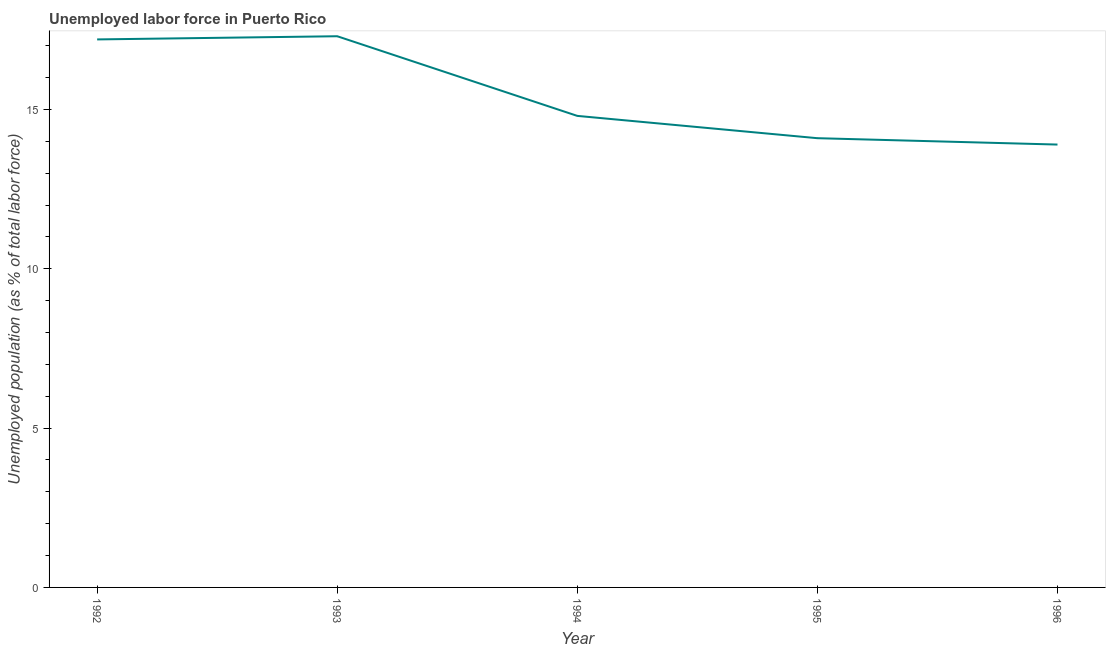What is the total unemployed population in 1996?
Make the answer very short. 13.9. Across all years, what is the maximum total unemployed population?
Provide a succinct answer. 17.3. Across all years, what is the minimum total unemployed population?
Your answer should be very brief. 13.9. In which year was the total unemployed population minimum?
Offer a very short reply. 1996. What is the sum of the total unemployed population?
Give a very brief answer. 77.3. What is the difference between the total unemployed population in 1992 and 1996?
Offer a very short reply. 3.3. What is the average total unemployed population per year?
Make the answer very short. 15.46. What is the median total unemployed population?
Give a very brief answer. 14.8. In how many years, is the total unemployed population greater than 8 %?
Your answer should be very brief. 5. Do a majority of the years between 1993 and 1992 (inclusive) have total unemployed population greater than 11 %?
Offer a very short reply. No. What is the ratio of the total unemployed population in 1994 to that in 1995?
Give a very brief answer. 1.05. Is the total unemployed population in 1993 less than that in 1995?
Your answer should be very brief. No. Is the difference between the total unemployed population in 1992 and 1995 greater than the difference between any two years?
Make the answer very short. No. What is the difference between the highest and the second highest total unemployed population?
Your answer should be compact. 0.1. What is the difference between the highest and the lowest total unemployed population?
Your response must be concise. 3.4. How many lines are there?
Make the answer very short. 1. How many years are there in the graph?
Provide a short and direct response. 5. Does the graph contain any zero values?
Keep it short and to the point. No. Does the graph contain grids?
Provide a short and direct response. No. What is the title of the graph?
Offer a very short reply. Unemployed labor force in Puerto Rico. What is the label or title of the Y-axis?
Offer a terse response. Unemployed population (as % of total labor force). What is the Unemployed population (as % of total labor force) in 1992?
Ensure brevity in your answer.  17.2. What is the Unemployed population (as % of total labor force) in 1993?
Ensure brevity in your answer.  17.3. What is the Unemployed population (as % of total labor force) in 1994?
Ensure brevity in your answer.  14.8. What is the Unemployed population (as % of total labor force) of 1995?
Your response must be concise. 14.1. What is the Unemployed population (as % of total labor force) in 1996?
Your answer should be compact. 13.9. What is the difference between the Unemployed population (as % of total labor force) in 1992 and 1993?
Give a very brief answer. -0.1. What is the difference between the Unemployed population (as % of total labor force) in 1992 and 1995?
Keep it short and to the point. 3.1. What is the difference between the Unemployed population (as % of total labor force) in 1992 and 1996?
Offer a terse response. 3.3. What is the difference between the Unemployed population (as % of total labor force) in 1993 and 1995?
Keep it short and to the point. 3.2. What is the difference between the Unemployed population (as % of total labor force) in 1994 and 1996?
Give a very brief answer. 0.9. What is the difference between the Unemployed population (as % of total labor force) in 1995 and 1996?
Make the answer very short. 0.2. What is the ratio of the Unemployed population (as % of total labor force) in 1992 to that in 1993?
Ensure brevity in your answer.  0.99. What is the ratio of the Unemployed population (as % of total labor force) in 1992 to that in 1994?
Offer a terse response. 1.16. What is the ratio of the Unemployed population (as % of total labor force) in 1992 to that in 1995?
Keep it short and to the point. 1.22. What is the ratio of the Unemployed population (as % of total labor force) in 1992 to that in 1996?
Provide a succinct answer. 1.24. What is the ratio of the Unemployed population (as % of total labor force) in 1993 to that in 1994?
Make the answer very short. 1.17. What is the ratio of the Unemployed population (as % of total labor force) in 1993 to that in 1995?
Give a very brief answer. 1.23. What is the ratio of the Unemployed population (as % of total labor force) in 1993 to that in 1996?
Offer a very short reply. 1.25. What is the ratio of the Unemployed population (as % of total labor force) in 1994 to that in 1995?
Give a very brief answer. 1.05. What is the ratio of the Unemployed population (as % of total labor force) in 1994 to that in 1996?
Give a very brief answer. 1.06. 